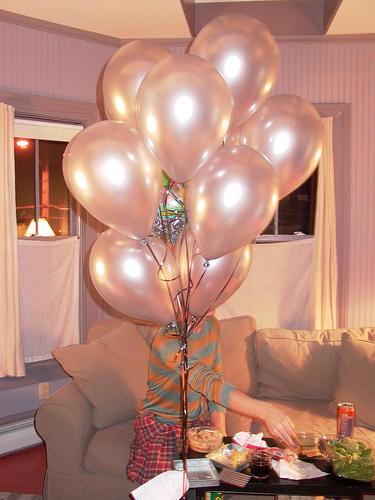<image>
Is the balloon behind the couch? No. The balloon is not behind the couch. From this viewpoint, the balloon appears to be positioned elsewhere in the scene. Is there a person in front of the balloon? No. The person is not in front of the balloon. The spatial positioning shows a different relationship between these objects. 